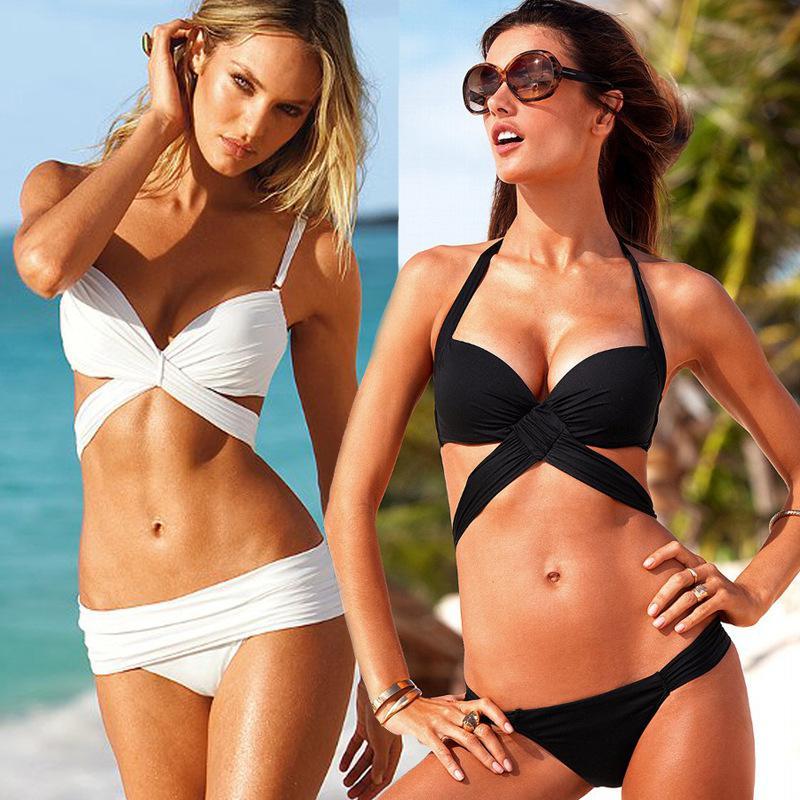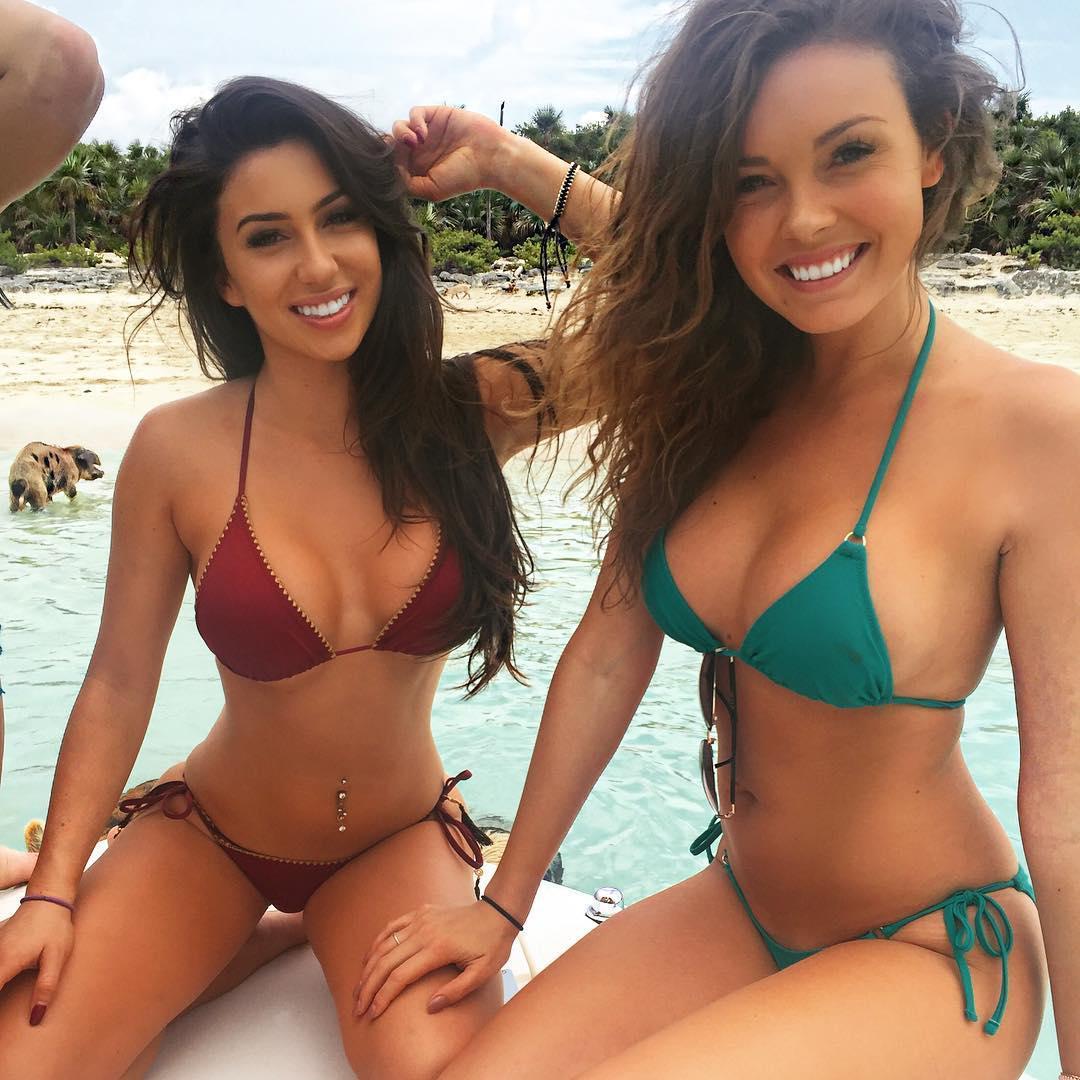The first image is the image on the left, the second image is the image on the right. Analyze the images presented: Is the assertion "At least one of the women in the image on the right is wearing sunglasses." valid? Answer yes or no. No. 